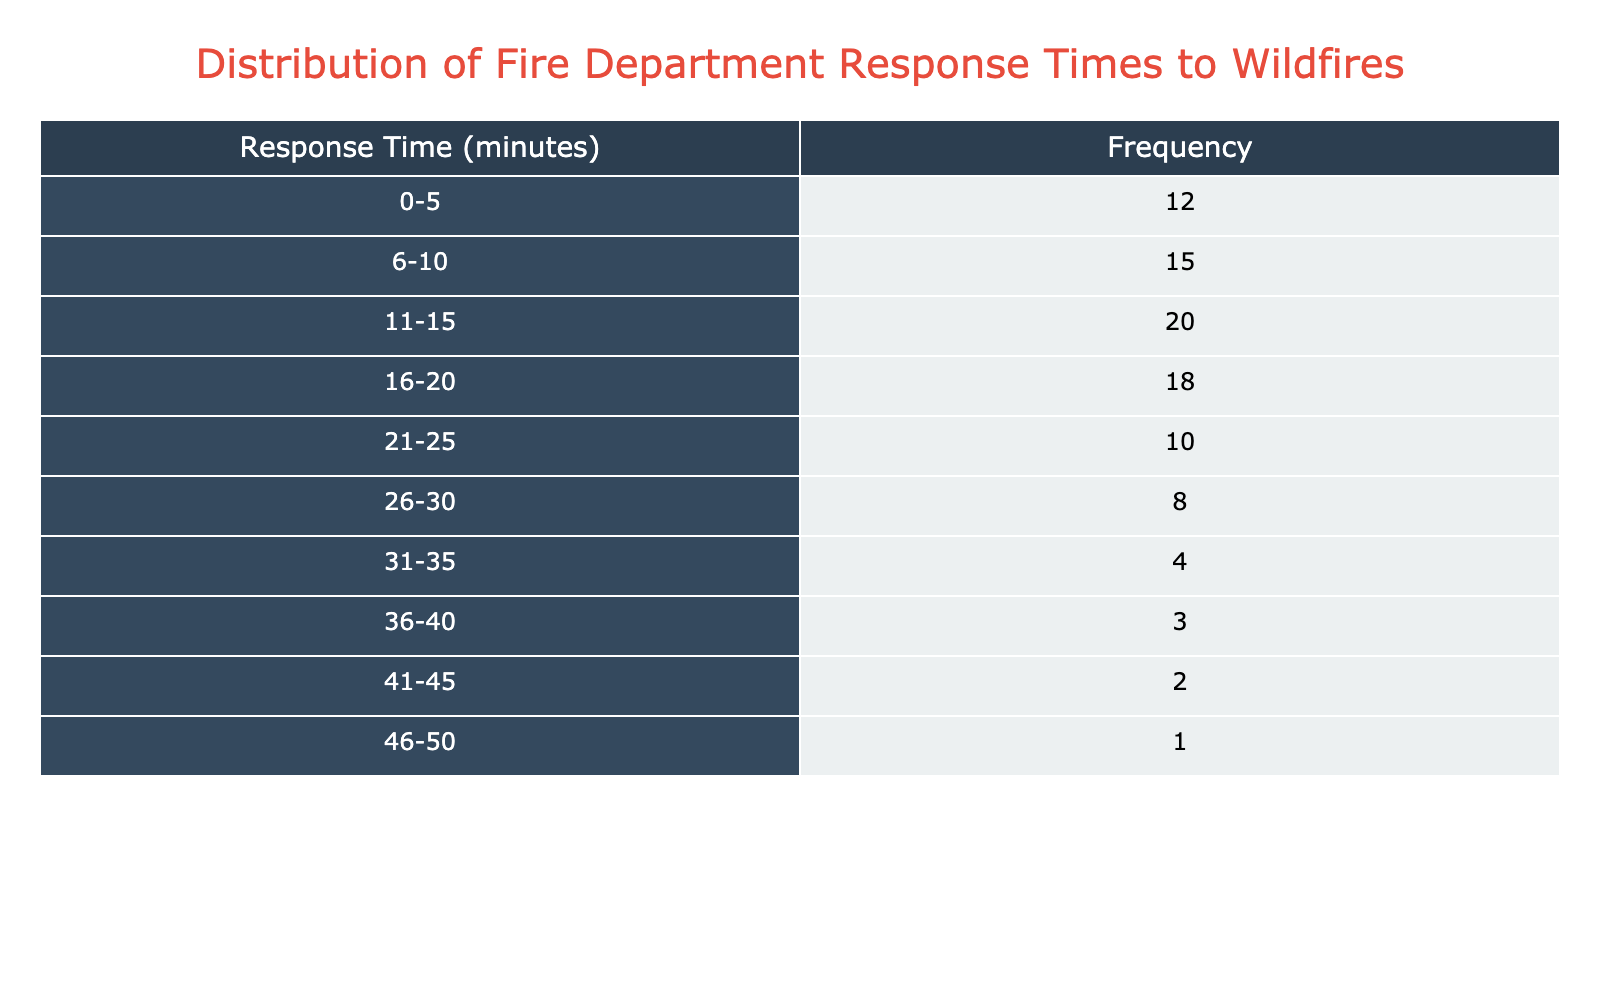What is the frequency of response times between 11 and 15 minutes? According to the table, the frequency for the response time range of 11-15 minutes is 20. This value can be directly read from the table in the 'Frequency' column corresponding to the 'Response Time' entry.
Answer: 20 What is the total frequency of response times that are 20 minutes or less? To find this total, we need to sum the frequencies of the response time intervals 0-5, 6-10, 11-15, and 16-20. Adding these gives: 12 + 15 + 20 + 18 = 65.
Answer: 65 Is there any response time category that has a frequency of more than 15? Looking through the frequencies in the table, the categories with frequencies greater than 15 are 11-15 (20), 16-20 (18), and 6-10 (15). Thus, the answer is yes.
Answer: Yes What is the difference in frequency between the response times of 1-5 minutes and 36-40 minutes? The frequency for 0-5 minutes is 12, and for 36-40 minutes is 3. Therefore, the difference is calculated as 12 - 3 = 9.
Answer: 9 What is the average response time considering the midpoints of each range? To find the average, we need to calculate the midpoint for each range and multiply by its frequency, then sum these products and divide by the total frequency. The midpoints are: (2.5, 8, 13, 18, 23, 28, 32.5, 38, 43.5, 48). The weighted sum: (2.5*12 + 8*15 + 13*20 + 18*18 + 23*10 + 28*8 + 32.5*4 + 38*3 + 43.5*2 + 48*1) and the total frequency is 100. The sum amounts to 686, hence the average = 686/100 = 6.86.
Answer: 6.86 How many response time categories have a frequency of fewer than 5? From the table, we see that the categories with frequencies below 5 are: 31-35 (4), 36-40 (3), 41-45 (2), and 46-50 (1). Counting these gives us a total of 4 categories.
Answer: 4 What response time interval has the highest frequency? Upon reviewing the table, the highest frequency is found in the interval 11-15 minutes, which has a frequency of 20. This can be seen directly in the frequency column.
Answer: 11-15 minutes Are there more response time categories with a frequency above 15 compared to those below 10? Examining the table, we find 3 categories have a frequency above 15 (11-15, 16-20, and 6-10) and 4 categories below 10 (31-35, 36-40, 41-45, and 46-50). Therefore, the statement that there are more above 15 is false.
Answer: No 